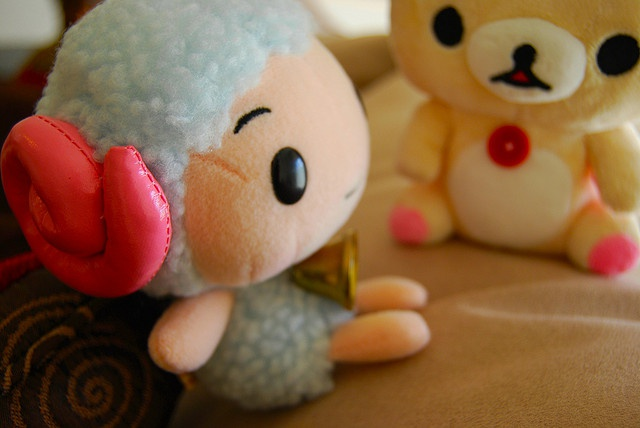Describe the objects in this image and their specific colors. I can see sheep in darkgray, gray, maroon, and tan tones, teddy bear in darkgray, gray, maroon, and brown tones, bed in darkgray, olive, black, gray, and maroon tones, and teddy bear in darkgray, olive, tan, and black tones in this image. 